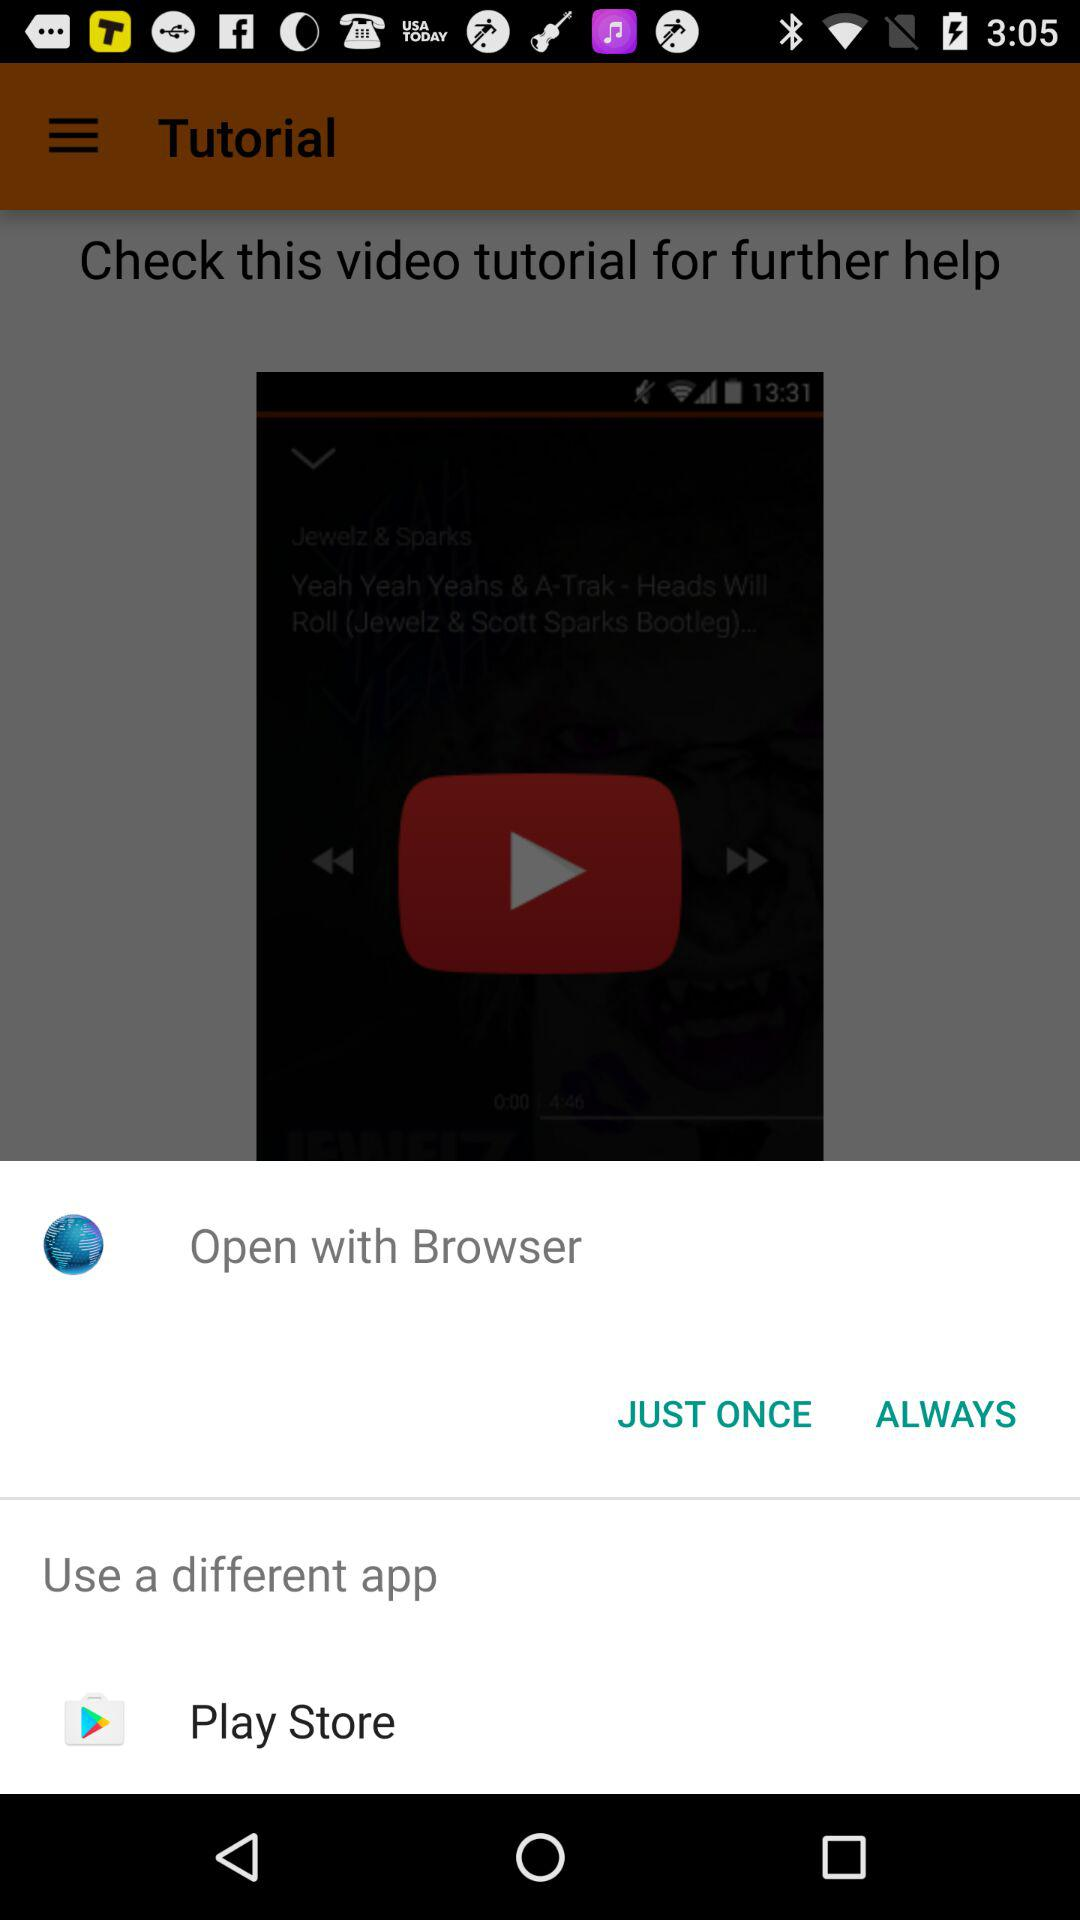What different apps can we use? You can use "Play Store". 